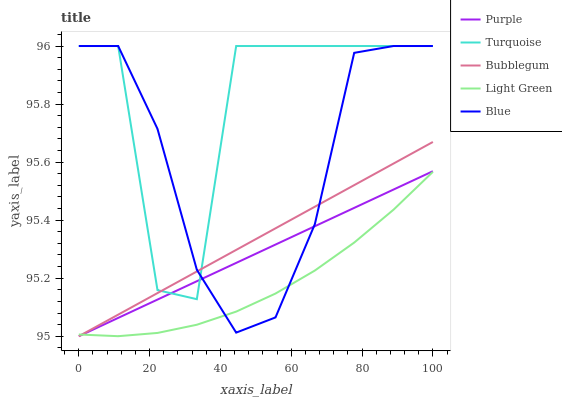Does Light Green have the minimum area under the curve?
Answer yes or no. Yes. Does Turquoise have the maximum area under the curve?
Answer yes or no. Yes. Does Blue have the minimum area under the curve?
Answer yes or no. No. Does Blue have the maximum area under the curve?
Answer yes or no. No. Is Purple the smoothest?
Answer yes or no. Yes. Is Turquoise the roughest?
Answer yes or no. Yes. Is Blue the smoothest?
Answer yes or no. No. Is Blue the roughest?
Answer yes or no. No. Does Blue have the lowest value?
Answer yes or no. No. Does Turquoise have the highest value?
Answer yes or no. Yes. Does Light Green have the highest value?
Answer yes or no. No. Is Light Green less than Turquoise?
Answer yes or no. Yes. Is Turquoise greater than Light Green?
Answer yes or no. Yes. Does Turquoise intersect Purple?
Answer yes or no. Yes. Is Turquoise less than Purple?
Answer yes or no. No. Is Turquoise greater than Purple?
Answer yes or no. No. Does Light Green intersect Turquoise?
Answer yes or no. No. 